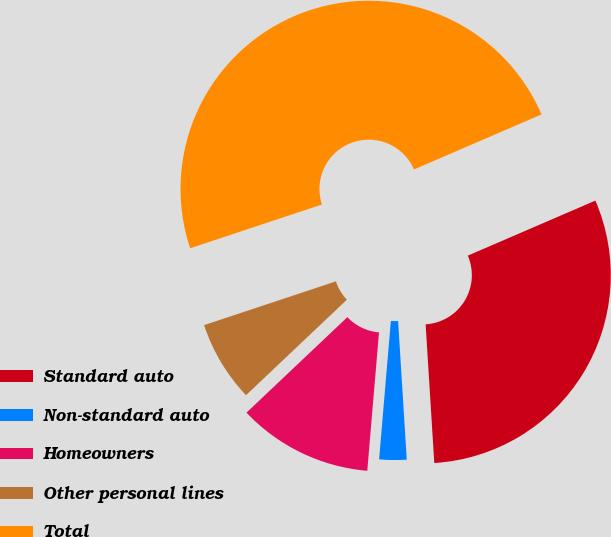Convert chart to OTSL. <chart><loc_0><loc_0><loc_500><loc_500><pie_chart><fcel>Standard auto<fcel>Non-standard auto<fcel>Homeowners<fcel>Other personal lines<fcel>Total<nl><fcel>30.49%<fcel>2.34%<fcel>11.59%<fcel>6.96%<fcel>48.62%<nl></chart> 